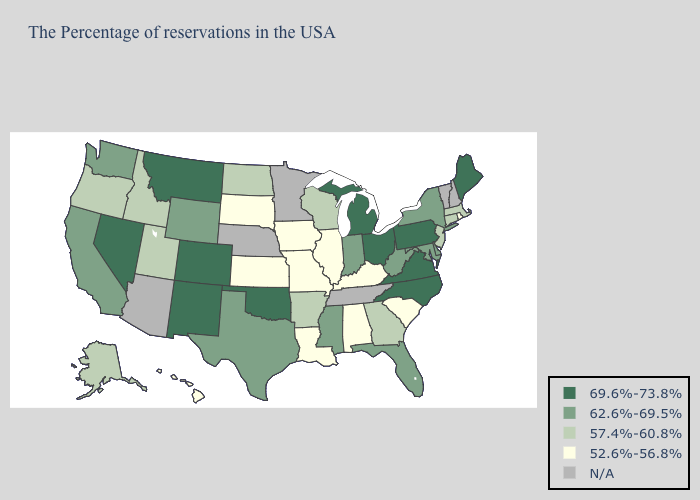Name the states that have a value in the range 69.6%-73.8%?
Give a very brief answer. Maine, Pennsylvania, Virginia, North Carolina, Ohio, Michigan, Oklahoma, Colorado, New Mexico, Montana, Nevada. Which states have the lowest value in the West?
Be succinct. Hawaii. What is the lowest value in states that border Kentucky?
Give a very brief answer. 52.6%-56.8%. What is the lowest value in the USA?
Be succinct. 52.6%-56.8%. Is the legend a continuous bar?
Keep it brief. No. What is the value of Texas?
Be succinct. 62.6%-69.5%. Does Michigan have the highest value in the MidWest?
Keep it brief. Yes. Among the states that border Colorado , which have the highest value?
Short answer required. Oklahoma, New Mexico. Name the states that have a value in the range 52.6%-56.8%?
Quick response, please. Rhode Island, South Carolina, Kentucky, Alabama, Illinois, Louisiana, Missouri, Iowa, Kansas, South Dakota, Hawaii. Name the states that have a value in the range 57.4%-60.8%?
Answer briefly. Massachusetts, Connecticut, New Jersey, Georgia, Wisconsin, Arkansas, North Dakota, Utah, Idaho, Oregon, Alaska. Among the states that border North Dakota , does Montana have the highest value?
Write a very short answer. Yes. Among the states that border New Hampshire , which have the lowest value?
Keep it brief. Massachusetts. What is the value of New Mexico?
Quick response, please. 69.6%-73.8%. Name the states that have a value in the range 69.6%-73.8%?
Short answer required. Maine, Pennsylvania, Virginia, North Carolina, Ohio, Michigan, Oklahoma, Colorado, New Mexico, Montana, Nevada. Name the states that have a value in the range 52.6%-56.8%?
Write a very short answer. Rhode Island, South Carolina, Kentucky, Alabama, Illinois, Louisiana, Missouri, Iowa, Kansas, South Dakota, Hawaii. 